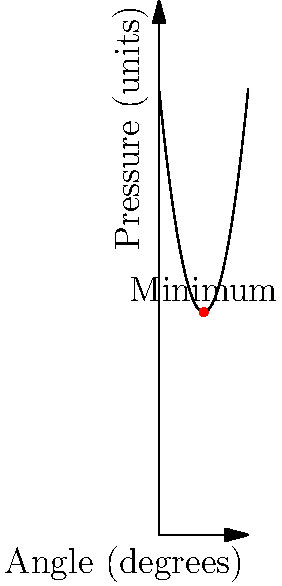A hospital bed needs to be adjusted to minimize pressure points for a patient with a rare neuroimmune disorder. The relationship between the bed angle (in degrees) and the pressure on the patient's body (in arbitrary units) is modeled by the function $P(\theta) = 0.5\theta^2 - 10\theta + 100$, where $\theta$ is the angle of inclination. Find the optimal angle to minimize pressure, and determine the minimum pressure at this angle. To find the optimal angle that minimizes pressure, we need to find the minimum of the function $P(\theta)$.

1) First, let's find the derivative of $P(\theta)$:
   $P'(\theta) = \theta - 10$

2) To find the minimum, set $P'(\theta) = 0$ and solve for $\theta$:
   $\theta - 10 = 0$
   $\theta = 10$

3) To confirm this is a minimum, check the second derivative:
   $P''(\theta) = 1 > 0$, so this is indeed a minimum.

4) The optimal angle is therefore 10 degrees.

5) To find the minimum pressure, plug $\theta = 10$ into the original function:
   $P(10) = 0.5(10)^2 - 10(10) + 100$
   $= 50 - 100 + 100 = 50$

Therefore, the optimal angle is 10 degrees, and the minimum pressure at this angle is 50 units.
Answer: Optimal angle: 10°; Minimum pressure: 50 units 